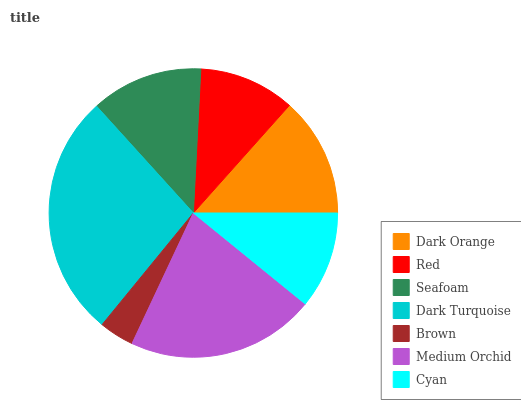Is Brown the minimum?
Answer yes or no. Yes. Is Dark Turquoise the maximum?
Answer yes or no. Yes. Is Red the minimum?
Answer yes or no. No. Is Red the maximum?
Answer yes or no. No. Is Dark Orange greater than Red?
Answer yes or no. Yes. Is Red less than Dark Orange?
Answer yes or no. Yes. Is Red greater than Dark Orange?
Answer yes or no. No. Is Dark Orange less than Red?
Answer yes or no. No. Is Seafoam the high median?
Answer yes or no. Yes. Is Seafoam the low median?
Answer yes or no. Yes. Is Dark Turquoise the high median?
Answer yes or no. No. Is Red the low median?
Answer yes or no. No. 